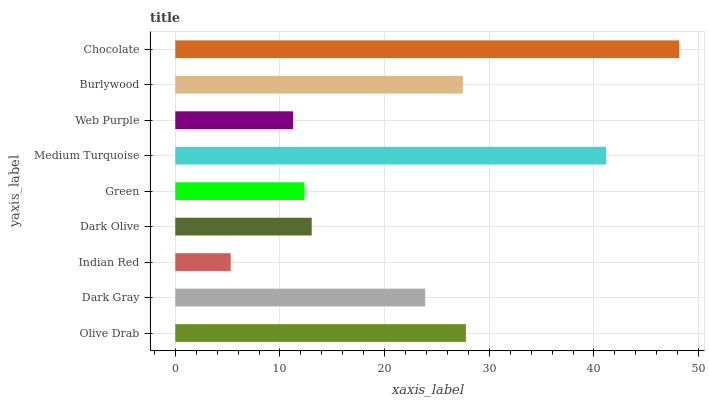Is Indian Red the minimum?
Answer yes or no. Yes. Is Chocolate the maximum?
Answer yes or no. Yes. Is Dark Gray the minimum?
Answer yes or no. No. Is Dark Gray the maximum?
Answer yes or no. No. Is Olive Drab greater than Dark Gray?
Answer yes or no. Yes. Is Dark Gray less than Olive Drab?
Answer yes or no. Yes. Is Dark Gray greater than Olive Drab?
Answer yes or no. No. Is Olive Drab less than Dark Gray?
Answer yes or no. No. Is Dark Gray the high median?
Answer yes or no. Yes. Is Dark Gray the low median?
Answer yes or no. Yes. Is Dark Olive the high median?
Answer yes or no. No. Is Chocolate the low median?
Answer yes or no. No. 